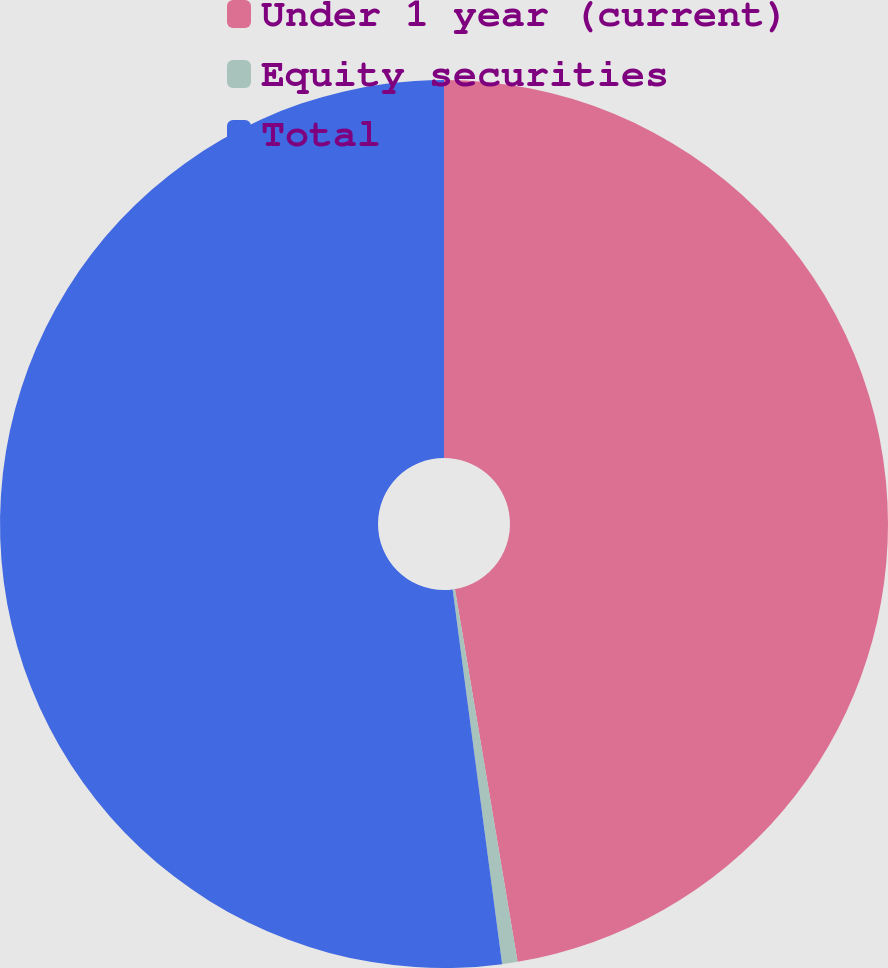Convert chart. <chart><loc_0><loc_0><loc_500><loc_500><pie_chart><fcel>Under 1 year (current)<fcel>Equity securities<fcel>Total<nl><fcel>47.35%<fcel>0.56%<fcel>52.09%<nl></chart> 